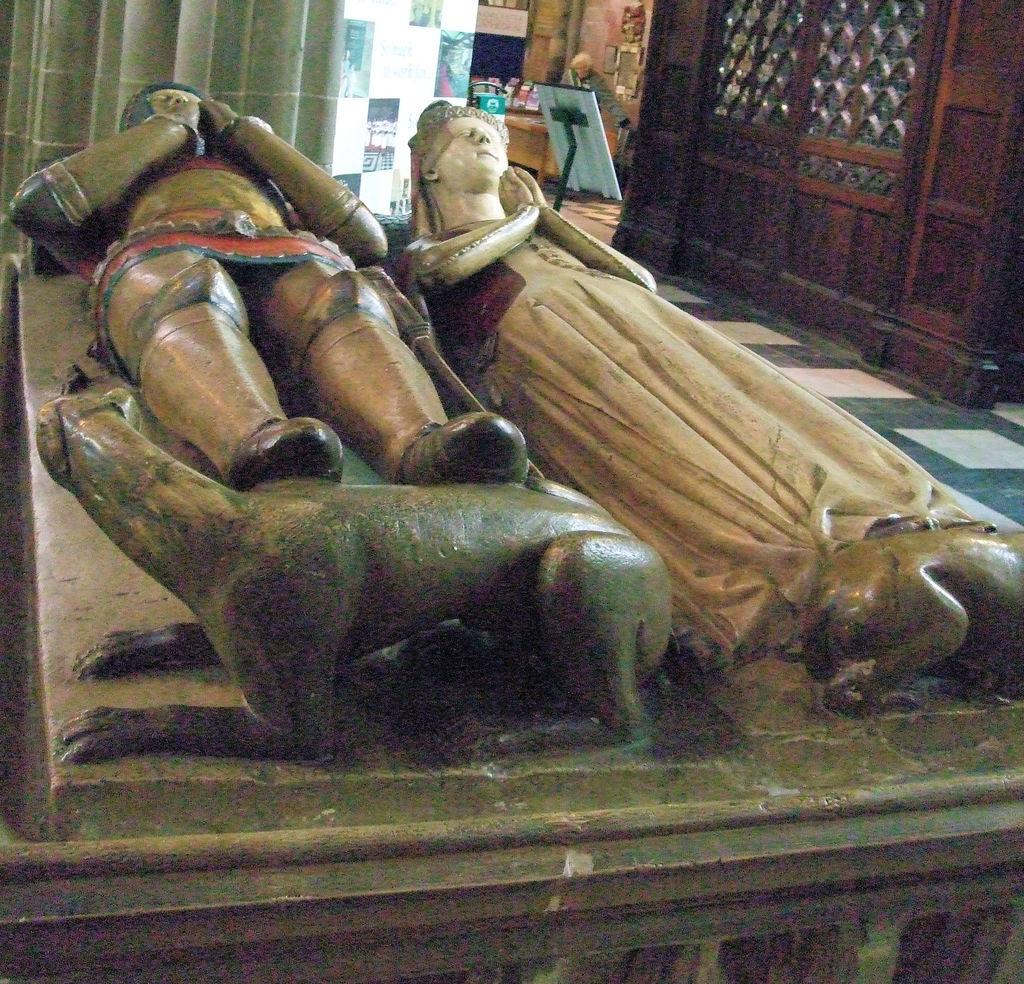What can be seen on the wall in the image? There are sculptures on a wall in the image. What is located in the top left corner of the image? There is a curtain in the top left of the image. What type of wall is visible in the top right corner of the image? There is a wooden wall in the top right of the image. What objects are beside the wooden wall? There are a few objects beside the wooden wall. What type of songs can be heard coming from the sculptures in the image? There are no sounds or songs coming from the sculptures in the image. Is there any quicksand visible in the image? There is no quicksand present in the image. 